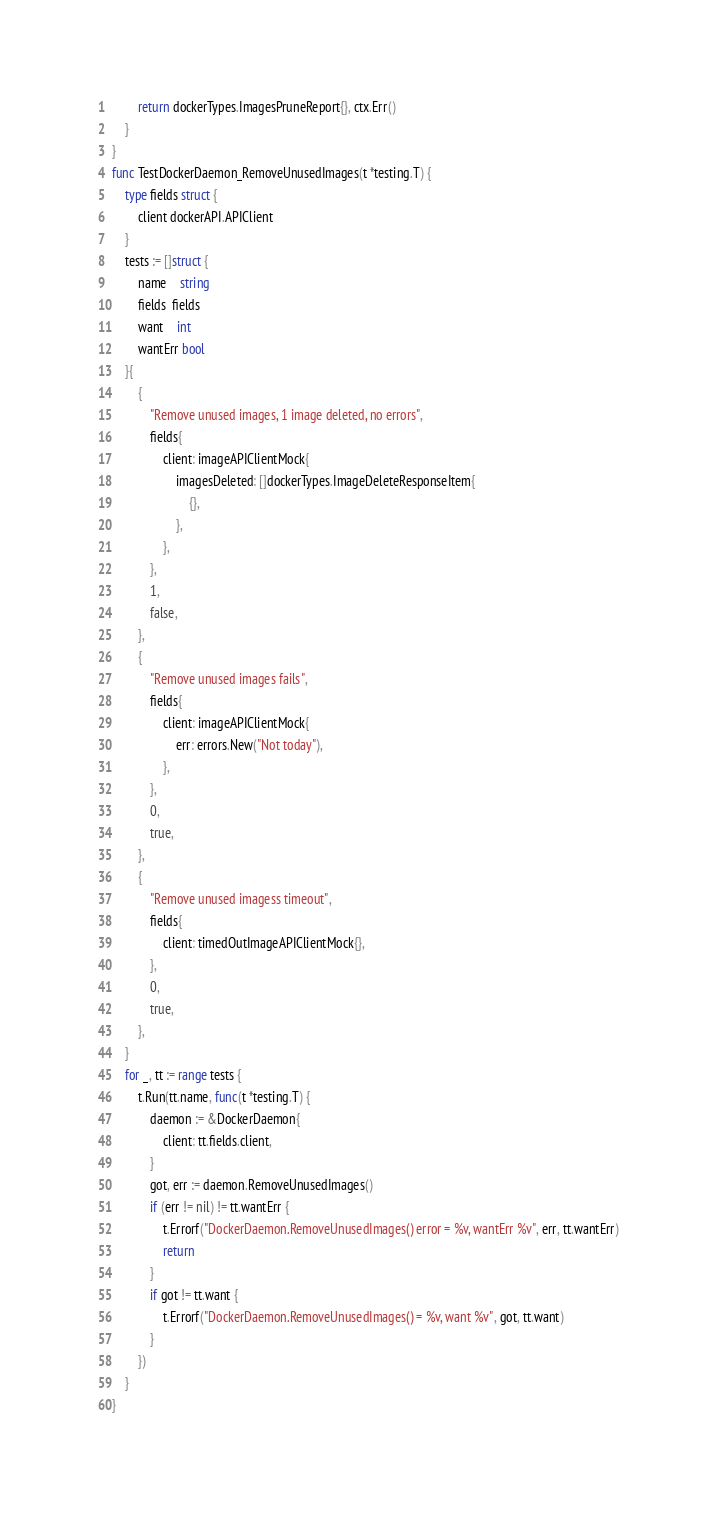<code> <loc_0><loc_0><loc_500><loc_500><_Go_>		return dockerTypes.ImagesPruneReport{}, ctx.Err()
	}
}
func TestDockerDaemon_RemoveUnusedImages(t *testing.T) {
	type fields struct {
		client dockerAPI.APIClient
	}
	tests := []struct {
		name    string
		fields  fields
		want    int
		wantErr bool
	}{
		{
			"Remove unused images, 1 image deleted, no errors",
			fields{
				client: imageAPIClientMock{
					imagesDeleted: []dockerTypes.ImageDeleteResponseItem{
						{},
					},
				},
			},
			1,
			false,
		},
		{
			"Remove unused images fails",
			fields{
				client: imageAPIClientMock{
					err: errors.New("Not today"),
				},
			},
			0,
			true,
		},
		{
			"Remove unused imagess timeout",
			fields{
				client: timedOutImageAPIClientMock{},
			},
			0,
			true,
		},
	}
	for _, tt := range tests {
		t.Run(tt.name, func(t *testing.T) {
			daemon := &DockerDaemon{
				client: tt.fields.client,
			}
			got, err := daemon.RemoveUnusedImages()
			if (err != nil) != tt.wantErr {
				t.Errorf("DockerDaemon.RemoveUnusedImages() error = %v, wantErr %v", err, tt.wantErr)
				return
			}
			if got != tt.want {
				t.Errorf("DockerDaemon.RemoveUnusedImages() = %v, want %v", got, tt.want)
			}
		})
	}
}
</code> 